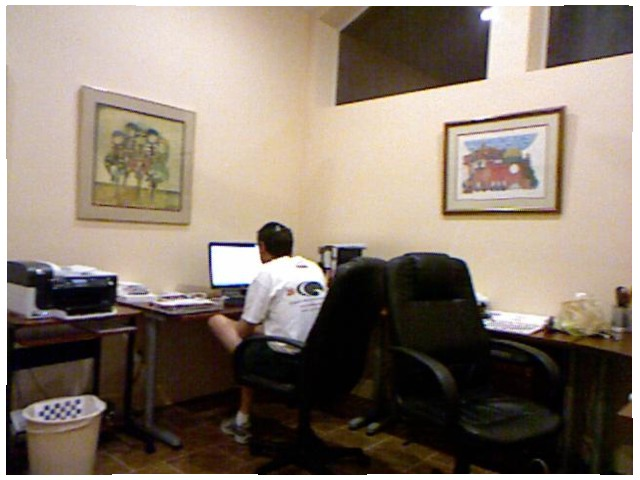<image>
Is the man under the window? Yes. The man is positioned underneath the window, with the window above it in the vertical space. Is there a person under the window? Yes. The person is positioned underneath the window, with the window above it in the vertical space. Is the chair under the photo frame? No. The chair is not positioned under the photo frame. The vertical relationship between these objects is different. Is the man in front of the system? Yes. The man is positioned in front of the system, appearing closer to the camera viewpoint. Where is the man in relation to the chair? Is it on the chair? Yes. Looking at the image, I can see the man is positioned on top of the chair, with the chair providing support. Where is the man in relation to the chair? Is it on the chair? No. The man is not positioned on the chair. They may be near each other, but the man is not supported by or resting on top of the chair. Where is the man in relation to the chair? Is it behind the chair? Yes. From this viewpoint, the man is positioned behind the chair, with the chair partially or fully occluding the man. 